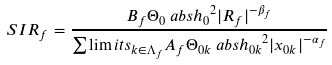Convert formula to latex. <formula><loc_0><loc_0><loc_500><loc_500>S I R _ { f } & = \frac { B _ { f } \Theta _ { 0 } \ a b s { h _ { 0 } } ^ { 2 } | R _ { f } | ^ { - \beta _ { f } } } { \sum \lim i t s _ { k \in \Lambda _ { f } } A _ { f } \Theta _ { 0 k } \ a b s { h _ { 0 k } } ^ { 2 } | x _ { 0 k } | ^ { - \alpha _ { f } } }</formula> 